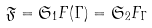Convert formula to latex. <formula><loc_0><loc_0><loc_500><loc_500>\mathfrak { F } = { \mathfrak { S } _ { 1 } F ( \Gamma ) } = { \mathfrak { S } _ { 2 } F _ { \Gamma } }</formula> 